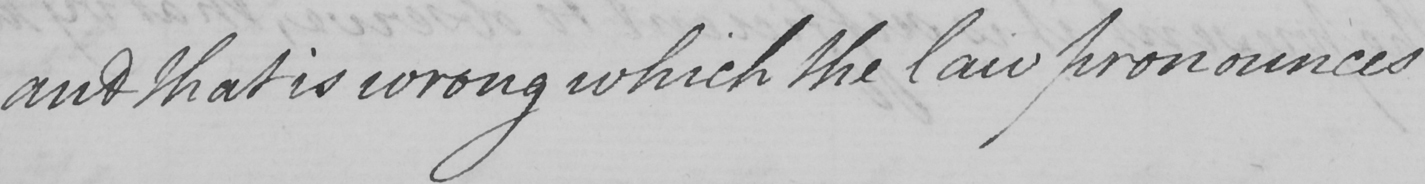What is written in this line of handwriting? and that is wrong which the law pronounces 